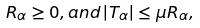Convert formula to latex. <formula><loc_0><loc_0><loc_500><loc_500>R _ { \alpha } \geq 0 , a n d \left | T _ { \alpha } \right | \leq \mu R _ { \alpha } ,</formula> 